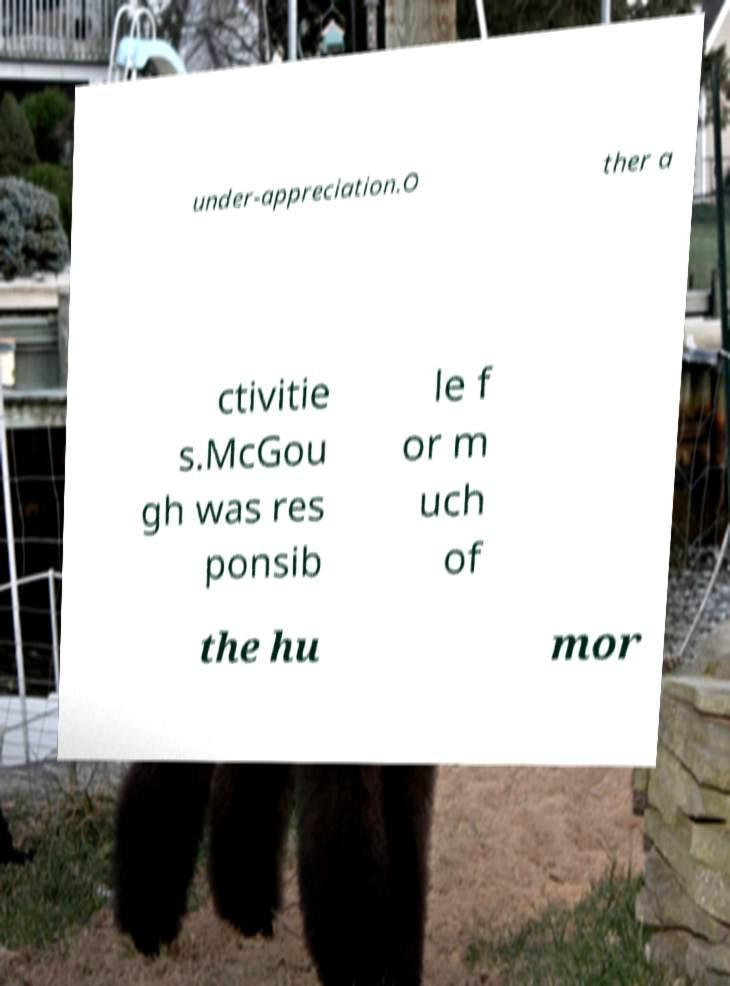What messages or text are displayed in this image? I need them in a readable, typed format. under-appreciation.O ther a ctivitie s.McGou gh was res ponsib le f or m uch of the hu mor 